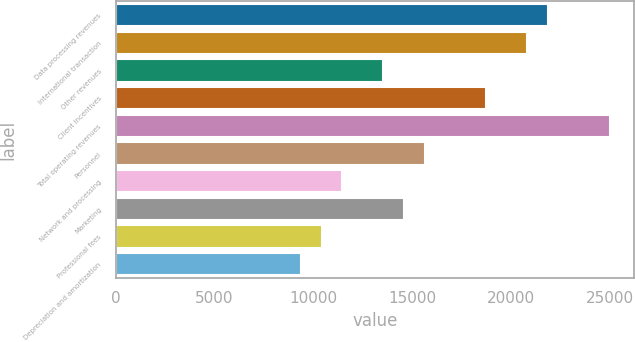<chart> <loc_0><loc_0><loc_500><loc_500><bar_chart><fcel>Data processing revenues<fcel>International transaction<fcel>Other revenues<fcel>Client incentives<fcel>Total operating revenues<fcel>Personnel<fcel>Network and processing<fcel>Marketing<fcel>Professional fees<fcel>Depreciation and amortization<nl><fcel>21882.6<fcel>20840.6<fcel>13546.9<fcel>18756.7<fcel>25008.4<fcel>15630.8<fcel>11463<fcel>14588.8<fcel>10421<fcel>9379.04<nl></chart> 